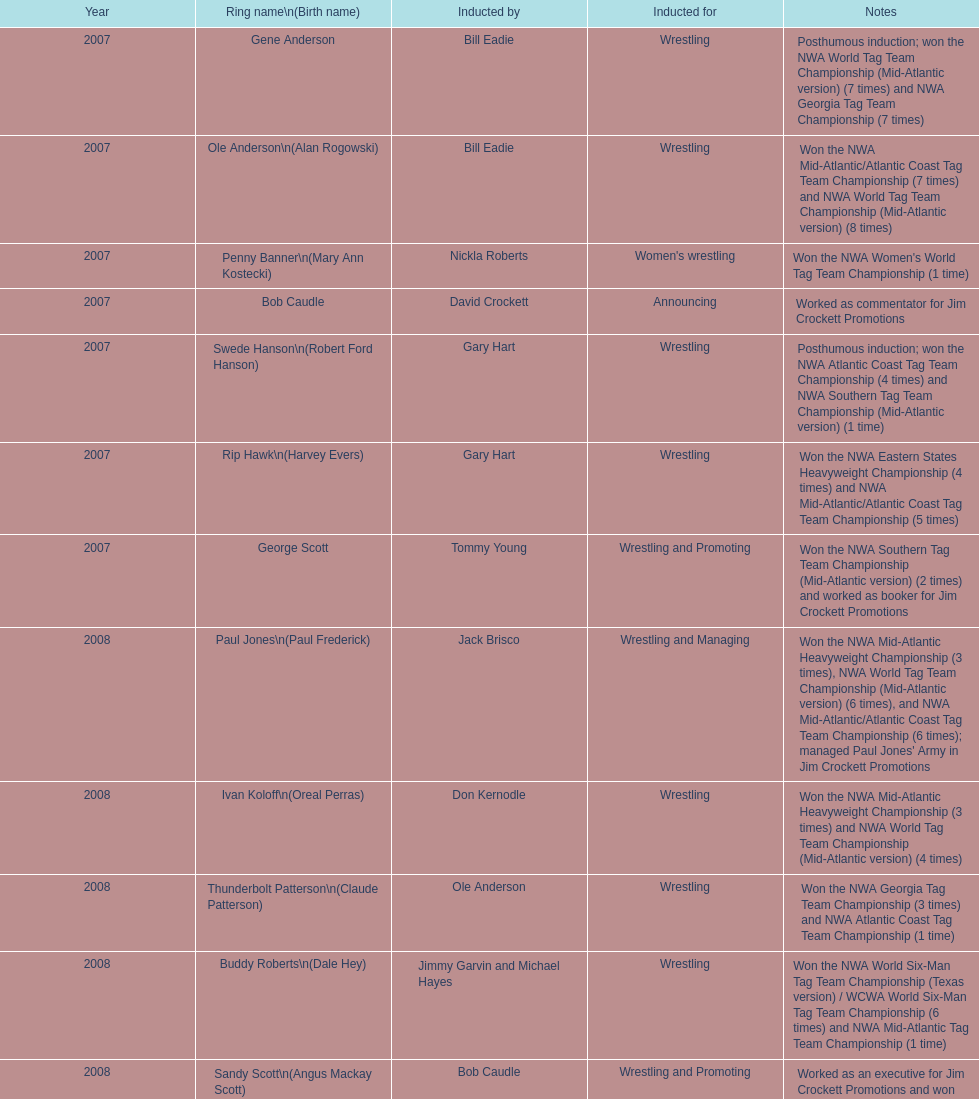Tell me an inductee that was not living at the time. Gene Anderson. 